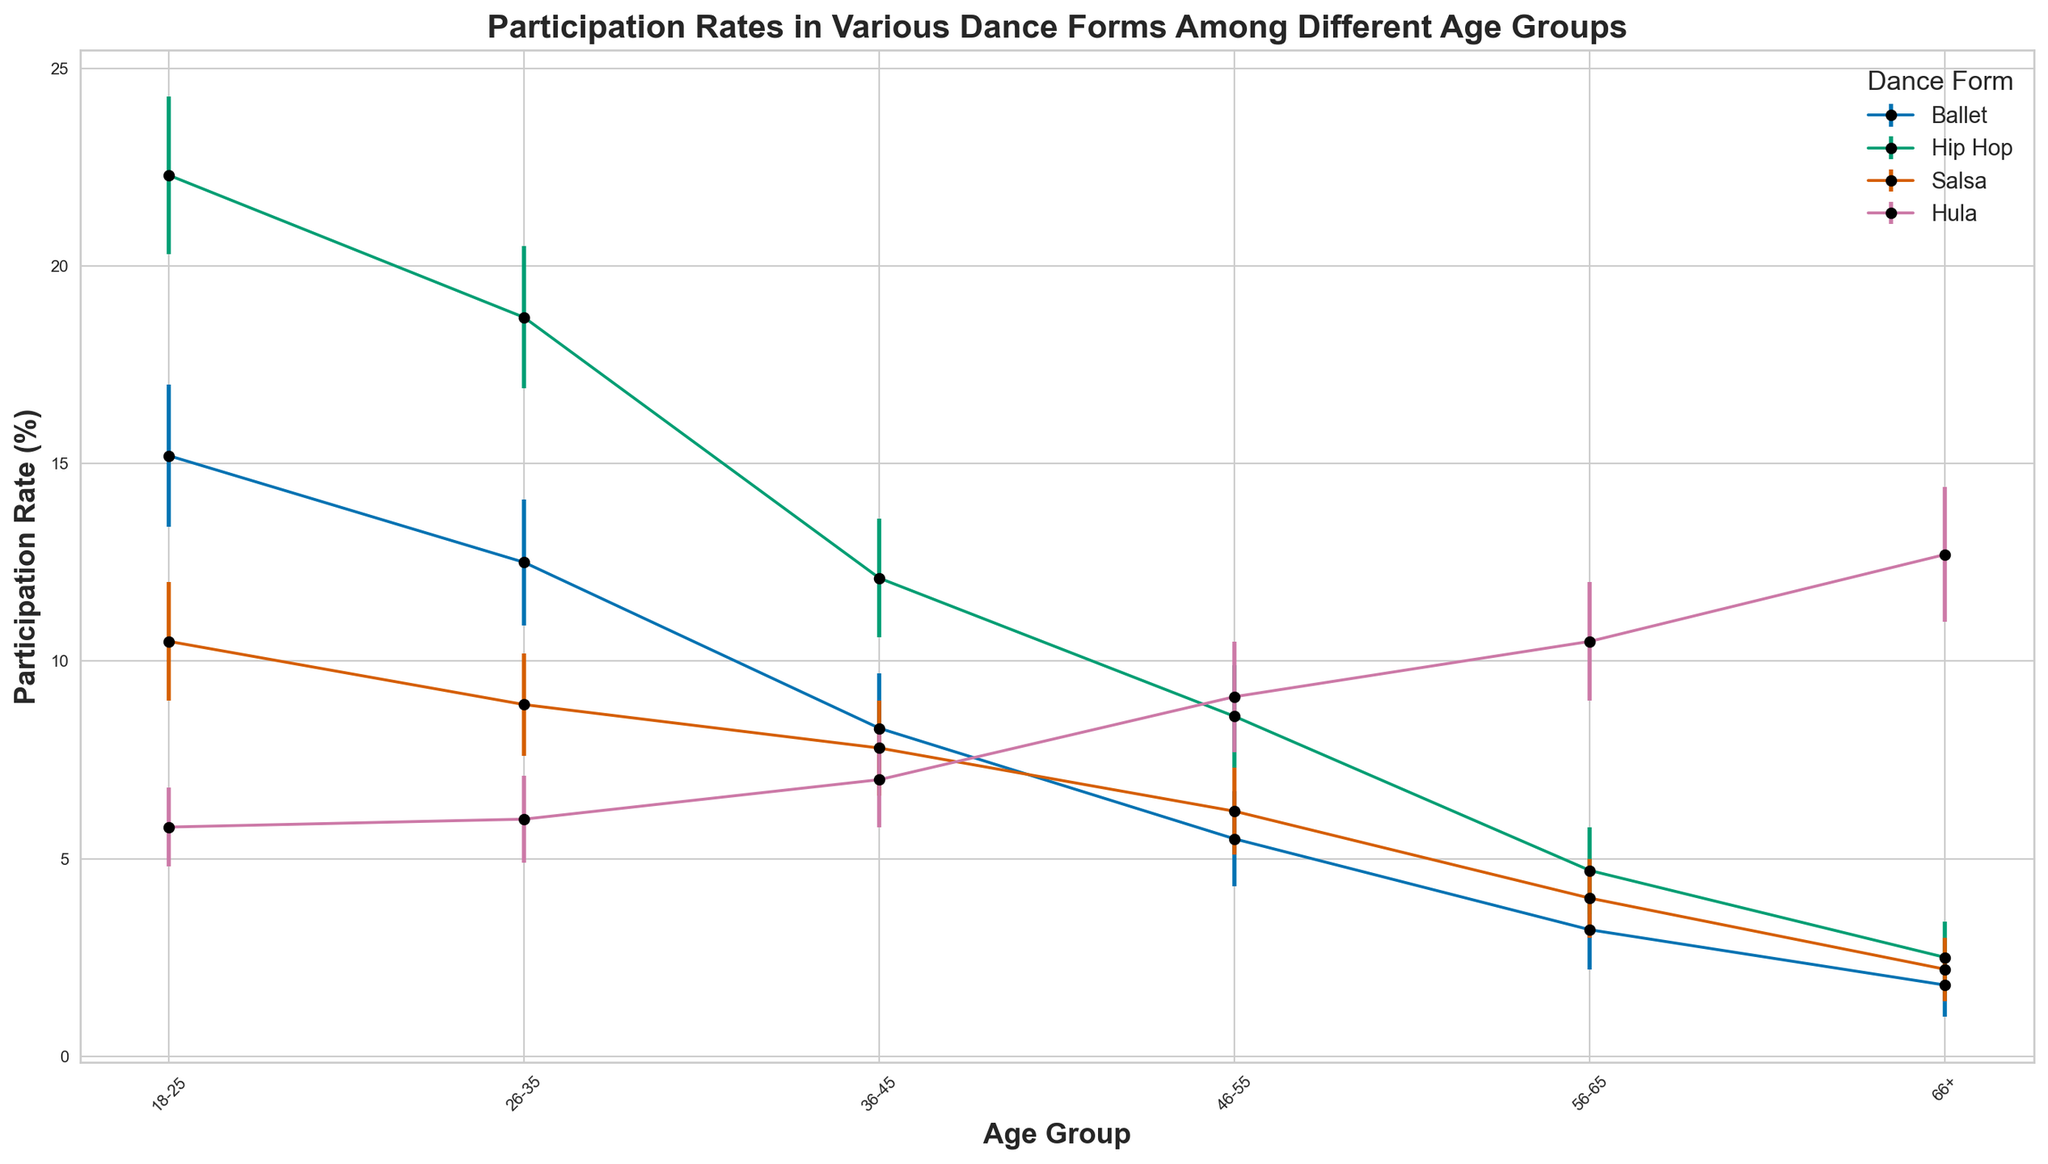Which age group has the highest participation rate in Hula? To determine the highest participation rate in Hula, look at the Hula line on the chart and find the peak value among all age groups. The highest point corresponds to the 66+ age group.
Answer: 66+ Which dance form has the lowest participation rate for the 18-25 age group? To find the dance form with the lowest participation rate for the 18-25 age group, look at the points aligned with 18-25 for each dance form. The lowest participation rate is for Hula.
Answer: Hula How does the participation rate in Salsa for the 26-35 age group compare to the 36-45 age group? Compare the points on the Salsa line for the 26-35 and 36-45 age groups. The participation rates are slightly higher for the 26-35 group (8.9%) compared to the 36-45 group (7.8%).
Answer: 26-35 > 36-45 What is the average participation rate of Ballet across all age groups? Sum up the Ballet participation rates for all age groups and divide by the number of age groups: (15.2 + 12.5 + 8.3 + 5.5 + 3.2 + 1.8) / 6 = 46.5 / 6.
Answer: 7.75 Is there an age group where Hula’s participation rate is higher than Salsa? Compare the Hula and Salsa lines for each age group. In the 46-55, 56-65, and 66+ age groups, Hula's participation rate is higher than Salsa's.
Answer: 46-55, 56-65, 66+ Which dance form has the most uniform participation rate across all age groups? To determine the most uniform participation, observe which line has the smallest fluctuation among age groups. Salsa's participation rate seems to vary the least compared to the others.
Answer: Salsa Does the participation rate in Hip Hop decrease with increasing age group? Observe the Hip Hop line and see if the participation rate consistently decreases as you move to higher age groups. This is true as the values drop from 18-25 to 66+.
Answer: Yes What is the total participation rate for Hula across all age groups? Sum the Hula participation rates for all age groups: 5.8 + 6.0 + 7.0 + 9.1 + 10.5 + 12.7 = 51.1.
Answer: 51.1 Which dance form shows the most significant increase in participation rate from the 56-65 to the 66+ age group? Compare the increase in participation rates between the 56-65 and 66+ age groups for each dance form. Hula shows the largest increase from 10.5% to 12.7%.
Answer: Hula Which age group shows the most diverse participation rates across the dance forms? Observe the spread of participation rates for each age group. The 18-25 age group displays the widest range from 5.8% in Hula to 22.3% in Hip Hop.
Answer: 18-25 